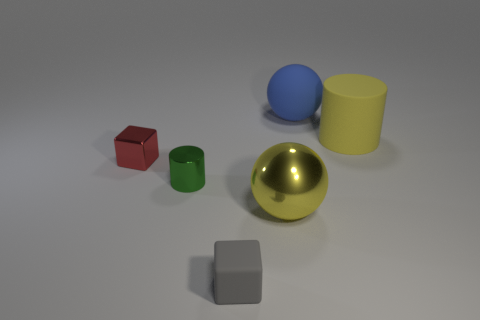What number of other things are there of the same color as the metallic sphere?
Offer a very short reply. 1. There is a large metallic sphere; does it have the same color as the cylinder that is behind the tiny red shiny thing?
Ensure brevity in your answer.  Yes. There is a sphere that is the same color as the large cylinder; what size is it?
Ensure brevity in your answer.  Large. Is there a large yellow matte object?
Your response must be concise. Yes. There is another thing that is the same shape as the blue matte object; what color is it?
Keep it short and to the point. Yellow. The shiny cylinder that is the same size as the gray thing is what color?
Your response must be concise. Green. Is the material of the small green cylinder the same as the big yellow cylinder?
Offer a terse response. No. What number of objects are the same color as the rubber cylinder?
Your answer should be compact. 1. Does the large cylinder have the same color as the metal ball?
Provide a short and direct response. Yes. What is the material of the sphere behind the big metallic sphere?
Ensure brevity in your answer.  Rubber. 